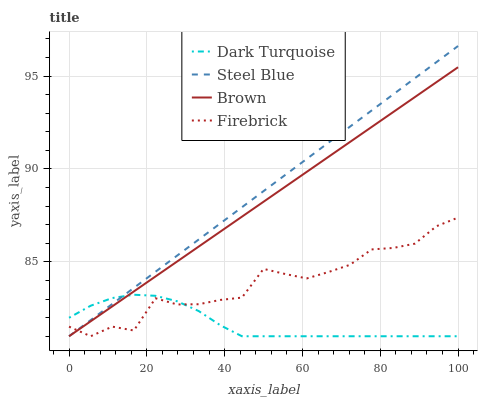Does Firebrick have the minimum area under the curve?
Answer yes or no. No. Does Firebrick have the maximum area under the curve?
Answer yes or no. No. Is Steel Blue the smoothest?
Answer yes or no. No. Is Steel Blue the roughest?
Answer yes or no. No. Does Firebrick have the highest value?
Answer yes or no. No. 